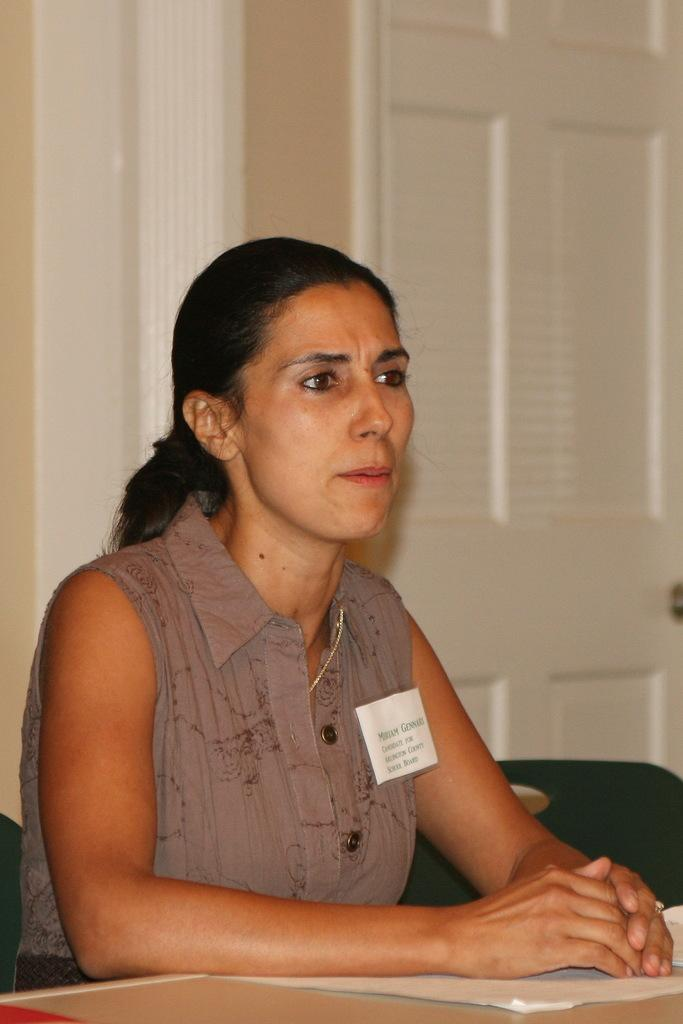Who is the main subject in the foreground of the image? There is a woman in the foreground of the image. What is the woman standing in front of? The woman is in front of a table. What can be seen in the background of the image? There is a wall visible in the background of the image. Where might this image have been taken? The image may have been taken in a hall, based on the presence of a table and wall. What type of foot can be seen in the image? There is no foot visible in the image; it only shows a woman in front of a table with a wall in the background. 